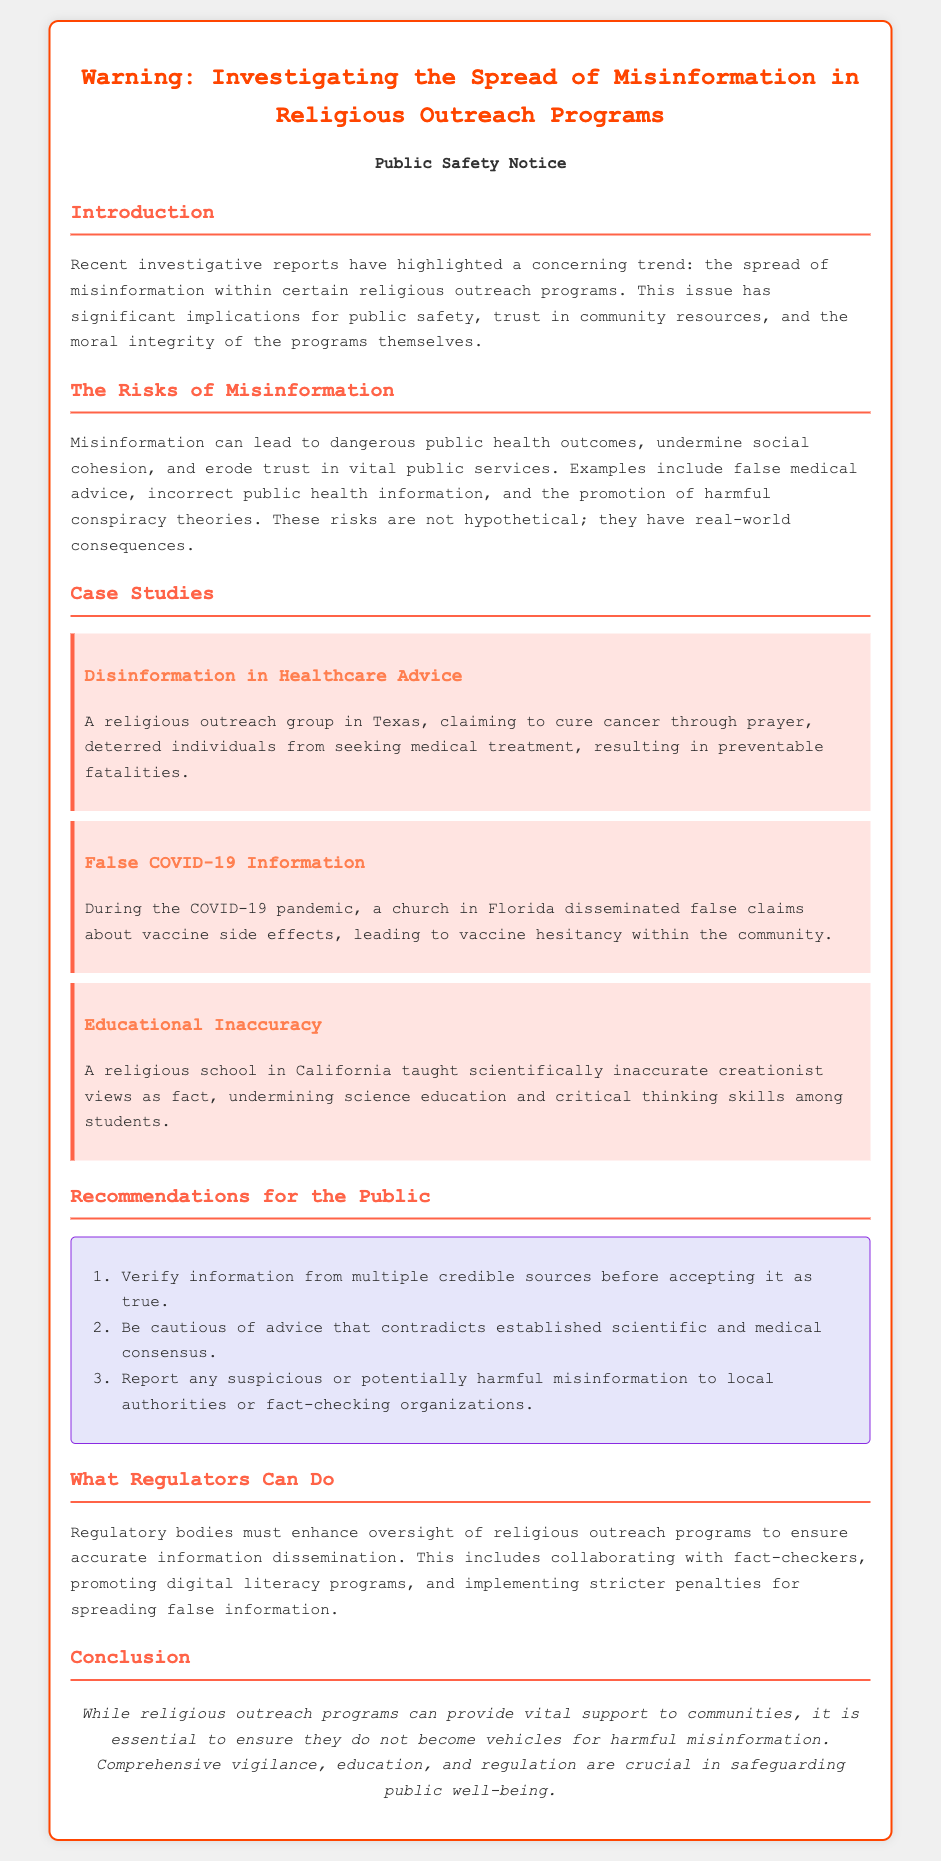What is the warning about? The warning highlights the spread of misinformation within certain religious outreach programs.
Answer: Misinformation in religious outreach programs What are the consequences of misinformation? The document states that misinformation can lead to dangerous public health outcomes and undermine social cohesion.
Answer: Dangerous public health outcomes Which state had a religious outreach group claiming to cure cancer? The case study mentions a group in Texas that made such claims.
Answer: Texas What misinformation was spread during the COVID-19 pandemic? A church in Florida disseminated false claims about vaccine side effects.
Answer: False claims about vaccine side effects What is one recommendation for the public? The document suggests verifying information from multiple credible sources before accepting it as true.
Answer: Verify information from multiple credible sources What should regulators do regarding religious outreach programs? Regulatory bodies must enhance oversight of religious outreach programs to ensure accurate information dissemination.
Answer: Enhance oversight How many case studies are presented? The document lists three case studies in the section.
Answer: Three What color is used for the conclusion text? The conclusion text is styled in an italic font.
Answer: Italic What is emphasized regarding the role of regulation? The document emphasizes the necessity of comprehensive vigilance, education, and regulation to safeguard public well-being.
Answer: Comprehensive vigilance, education, and regulation 